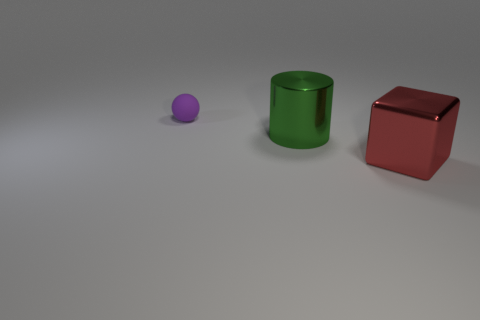Add 3 cyan shiny objects. How many objects exist? 6 Subtract all balls. How many objects are left? 2 Add 2 small matte objects. How many small matte objects are left? 3 Add 3 green objects. How many green objects exist? 4 Subtract 0 green balls. How many objects are left? 3 Subtract all big red metallic blocks. Subtract all metal objects. How many objects are left? 0 